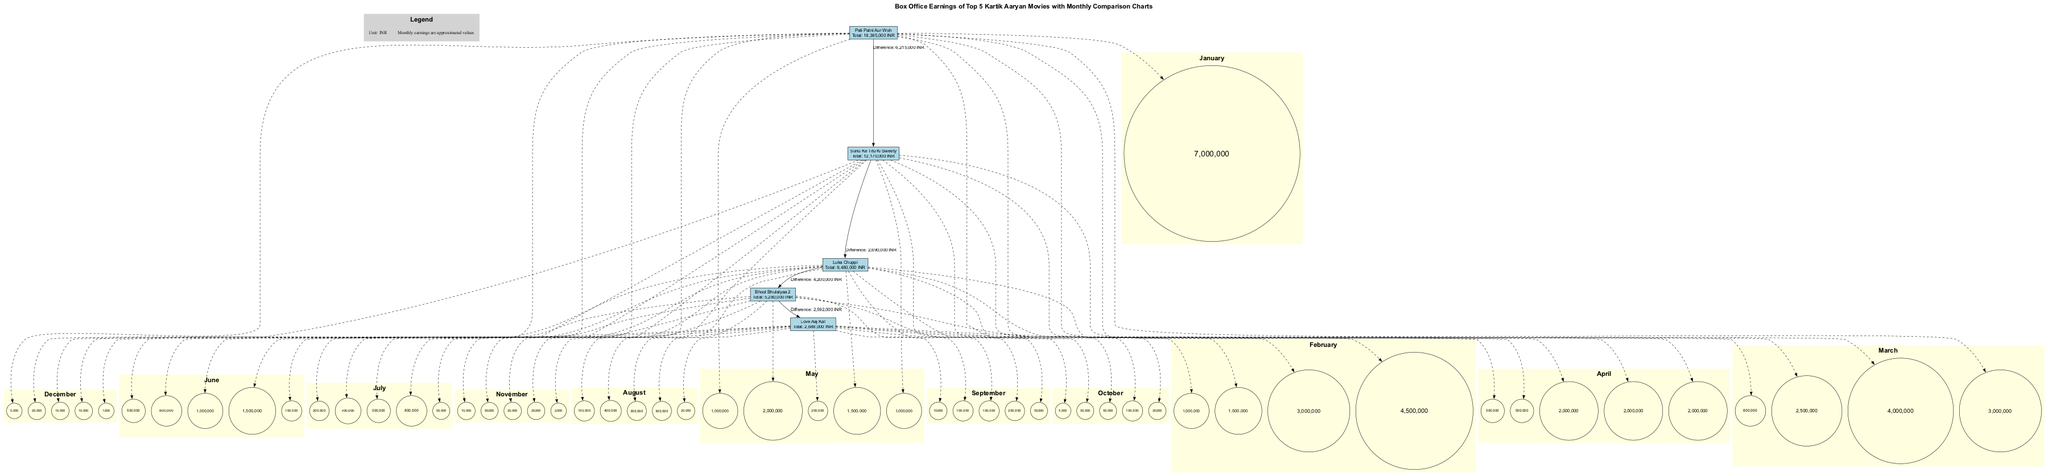What's the total box office earning of "Bhool Bhulaiyaa 2"? The diagram shows the node for "Bhool Bhulaiyaa 2" which details the total earnings. By adding up its monthly earnings, I find the total to be five million six hundred thousand INR.
Answer: Five million six hundred thousand INR Which movie had the highest total earnings? The diagram presents nodes connected by edges showing total earnings. By comparing the total values displayed in each movie's respective node, it's clear that "Pati Patni Aur Woh" has the highest total earnings of twenty million five hundred thousand INR.
Answer: Twenty million five hundred thousand INR What is the difference in earnings between "Sonu Ke Titu Ki Sweety" and "Luka Chuppi"? There are edges labeled with differences between earnings. I find "Sonu Ke Titu Ki Sweety" earned a total of ten million three hundred thousand INR, while "Luka Chuppi" earned nine million five hundred thousand INR. Thus, the difference is eight hundred thousand INR.
Answer: Eight hundred thousand INR In which month did "Pati Patni Aur Woh" earn the most? The diagram includes subgraphs for each month showing earnings in circles. By searching through the monthly earnings for "Pati Patni Aur Woh," I see that it earned seven million in January, which is the highest among all months.
Answer: January How much did "Love Aaj Kal" earn in March? To answer this, I refer to the monthly subgraph for March specifically for the "Love Aaj Kal" node. The monthly earnings for March are shown as eight hundred thousand INR.
Answer: Eight hundred thousand INR What is the total number of movies listed in the diagram? The diagram displays boxes representing each movie. Counting these nodes, I find there are five distinct movie nodes represented in the diagram.
Answer: Five 